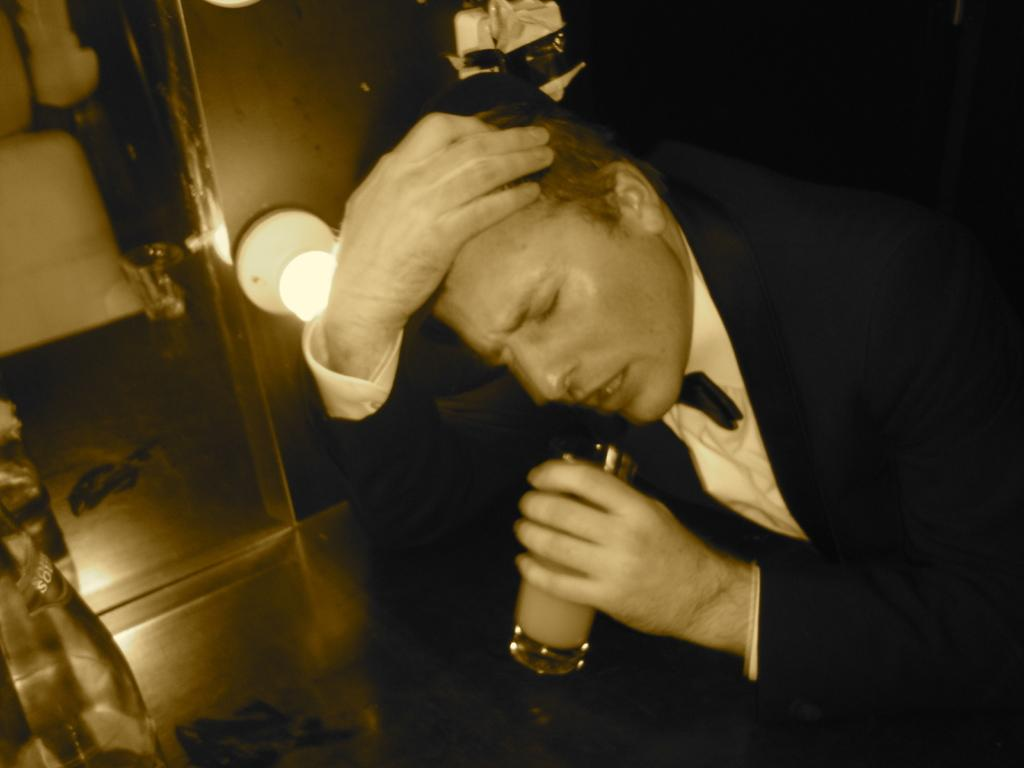Who or what is present in the image? There is a person in the image. What is the person holding in the image? The person is holding a glass. Can you describe the person's attire in the image? The person is wearing a black blazer and a white shirt. What can be seen in the background of the image? There is a light in the background of the image. What type of chalk is the person using to draw on the crib in the image? There is no crib or chalk present in the image. Can you describe the person's eye color in the image? The provided facts do not mention the person's eye color, so it cannot be determined from the image. 